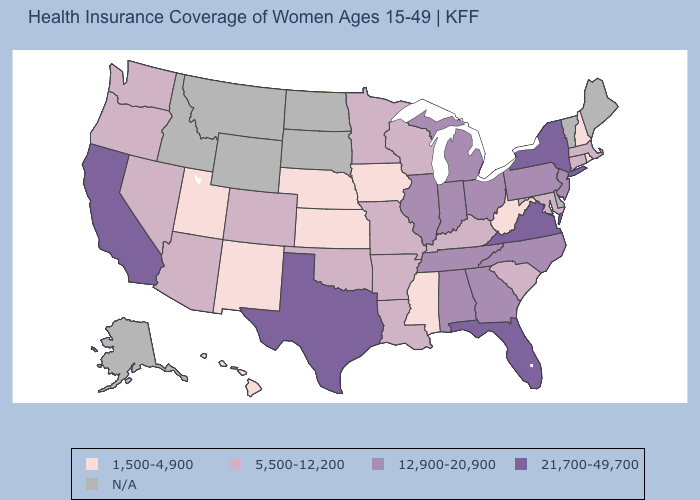Among the states that border North Carolina , does Georgia have the highest value?
Be succinct. No. Is the legend a continuous bar?
Be succinct. No. What is the value of North Dakota?
Give a very brief answer. N/A. Does the map have missing data?
Short answer required. Yes. What is the lowest value in the South?
Keep it brief. 1,500-4,900. What is the highest value in states that border New Jersey?
Concise answer only. 21,700-49,700. What is the lowest value in the MidWest?
Be succinct. 1,500-4,900. Is the legend a continuous bar?
Give a very brief answer. No. Which states have the highest value in the USA?
Quick response, please. California, Florida, New York, Texas, Virginia. What is the value of Arizona?
Keep it brief. 5,500-12,200. What is the lowest value in the Northeast?
Keep it brief. 1,500-4,900. Does the first symbol in the legend represent the smallest category?
Be succinct. Yes. Is the legend a continuous bar?
Quick response, please. No. Does Arkansas have the highest value in the South?
Concise answer only. No. 